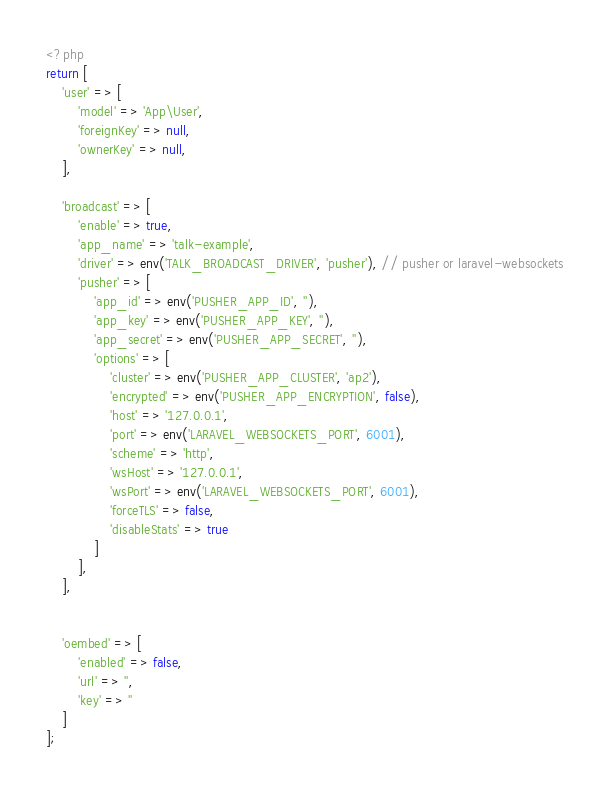Convert code to text. <code><loc_0><loc_0><loc_500><loc_500><_PHP_><?php
return [
    'user' => [
        'model' => 'App\User',
        'foreignKey' => null,
        'ownerKey' => null,
    ],

    'broadcast' => [
        'enable' => true,
        'app_name' => 'talk-example',
        'driver' => env('TALK_BROADCAST_DRIVER', 'pusher'), // pusher or laravel-websockets
        'pusher' => [
            'app_id' => env('PUSHER_APP_ID', ''),
            'app_key' => env('PUSHER_APP_KEY', ''),
            'app_secret' => env('PUSHER_APP_SECRET', ''),
            'options' => [
                'cluster' => env('PUSHER_APP_CLUSTER', 'ap2'),
                'encrypted' => env('PUSHER_APP_ENCRYPTION', false),
                'host' => '127.0.0.1',
                'port' => env('LARAVEL_WEBSOCKETS_PORT', 6001),
                'scheme' => 'http',
                'wsHost' => '127.0.0.1',
                'wsPort' => env('LARAVEL_WEBSOCKETS_PORT', 6001),
                'forceTLS' => false,
                'disableStats' => true
            ]
        ],
    ],


    'oembed' => [
        'enabled' => false,
        'url' => '',
        'key' => ''
    ]
];
</code> 